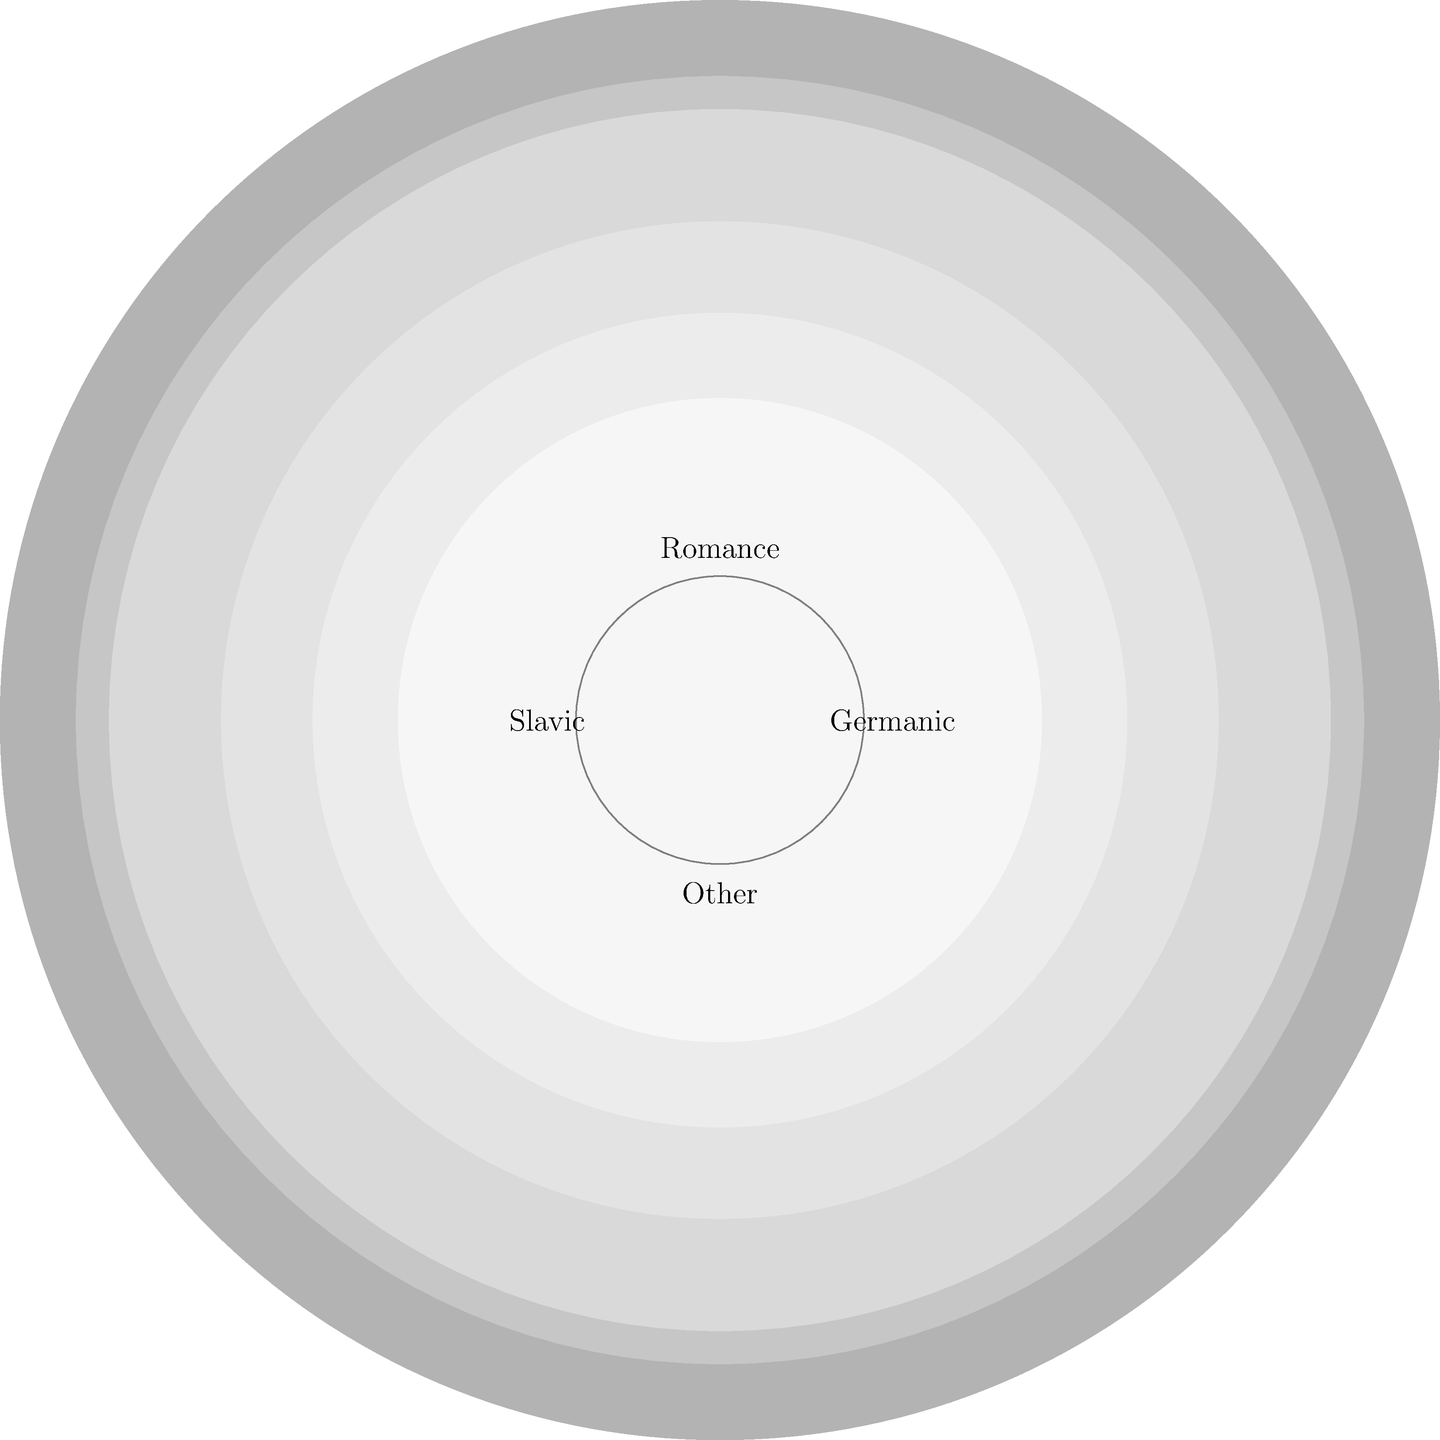In the polar area diagram representing the linguistic distribution across Europe, which language family appears to have the largest area, indicating the highest number of speakers? To determine which language family has the largest area in the polar area diagram, we need to follow these steps:

1. Identify the language families represented:
   - The diagram is divided into four main sections, presumably representing Germanic, Romance, Slavic, and Other language families.

2. Analyze the areas:
   - In a polar area diagram, the area of each sector is proportional to the value it represents.
   - The area is determined by both the angle and the radius of the sector.

3. Compare the sectors:
   - The Germanic languages (top-right quadrant) appear to have the largest continuous area.
   - The Romance languages (top-left quadrant) have the second-largest area.
   - Slavic languages (bottom-left quadrant) and Other languages (bottom-right quadrant) have smaller areas.

4. Consider the implications:
   - A larger area in this diagram corresponds to a higher number of speakers or a more widespread use of the language family in Europe.

5. Conclude:
   - Based on the visual representation, the Germanic language family appears to have the largest area, indicating it has the highest number of speakers or most widespread usage in Europe.

This aligns with the linguistic reality in Europe, where Germanic languages (including English, German, Dutch, and Scandinavian languages) are indeed widely spoken across several countries and used in international communication.
Answer: Germanic languages 